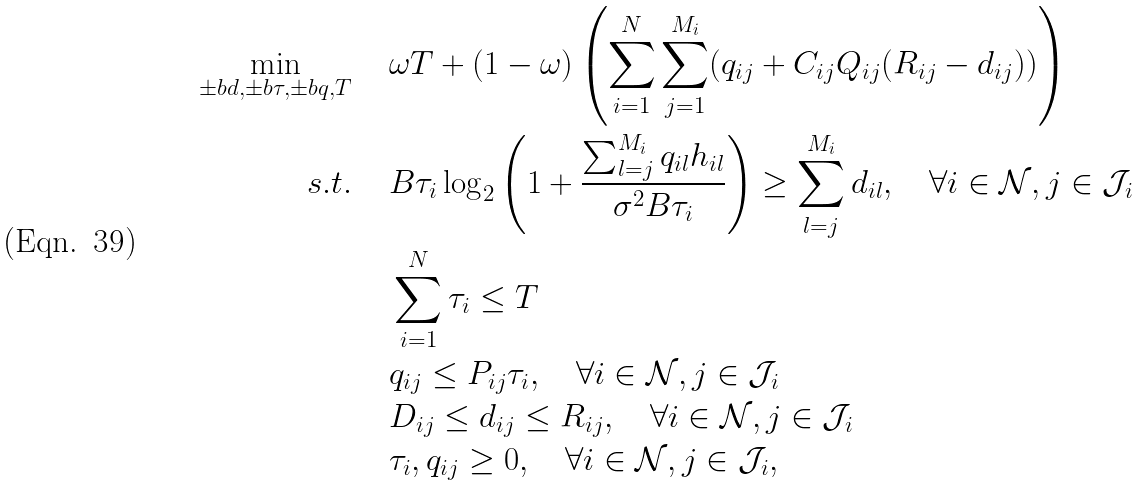<formula> <loc_0><loc_0><loc_500><loc_500>\min _ { \pm b d , \pm b \tau , \pm b q , T } \, \quad & \omega T + ( 1 - \omega ) \left ( \sum _ { i = 1 } ^ { N } \sum _ { j = 1 } ^ { M _ { i } } ( q _ { i j } + C _ { i j } Q _ { i j } ( R _ { i j } - d _ { i j } ) ) \right ) \\ s . t . \quad \, & B \tau _ { i } \log _ { 2 } \left ( 1 + \frac { \sum _ { l = j } ^ { M _ { i } } q _ { i l } h _ { i l } } { \sigma ^ { 2 } B \tau _ { i } } \right ) \geq \sum _ { l = j } ^ { M _ { i } } d _ { i l } , \quad \forall i \in \mathcal { N } , j \in \mathcal { J } _ { i } \\ & \sum _ { i = 1 } ^ { N } \tau _ { i } \leq T \\ & q _ { i j } \leq P _ { i j } \tau _ { i } , \quad \forall i \in \mathcal { N } , j \in \mathcal { J } _ { i } \\ & D _ { i j } \leq d _ { i j } \leq R _ { i j } , \quad \forall i \in \mathcal { N } , j \in \mathcal { J } _ { i } \\ & \tau _ { i } , q _ { i j } \geq 0 , \quad \forall i \in \mathcal { N } , j \in \mathcal { J } _ { i } ,</formula> 